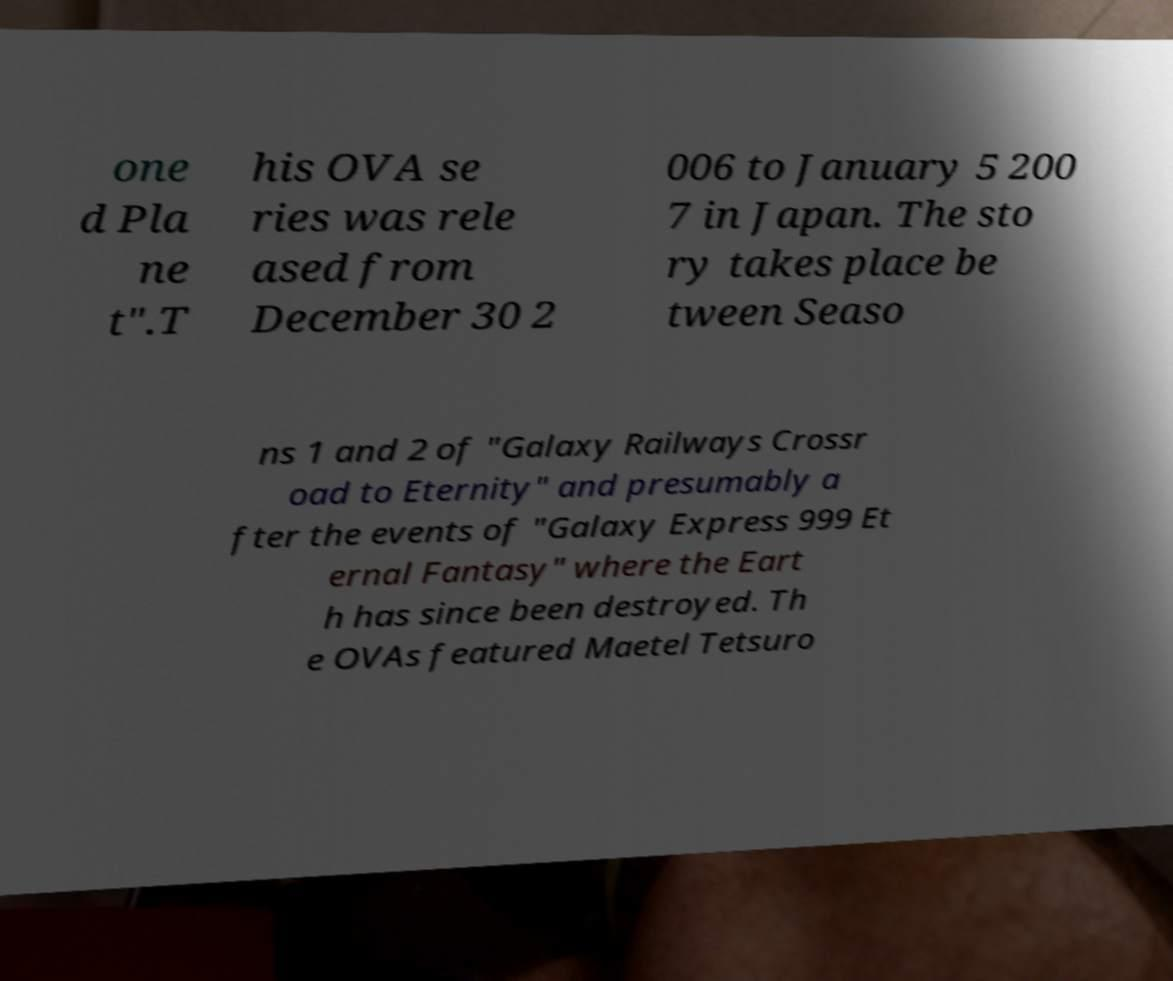Can you accurately transcribe the text from the provided image for me? one d Pla ne t".T his OVA se ries was rele ased from December 30 2 006 to January 5 200 7 in Japan. The sto ry takes place be tween Seaso ns 1 and 2 of "Galaxy Railways Crossr oad to Eternity" and presumably a fter the events of "Galaxy Express 999 Et ernal Fantasy" where the Eart h has since been destroyed. Th e OVAs featured Maetel Tetsuro 